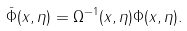<formula> <loc_0><loc_0><loc_500><loc_500>\bar { \Phi } ( x , \eta ) = \Omega ^ { - 1 } ( x , \eta ) \Phi ( x , \eta ) .</formula> 